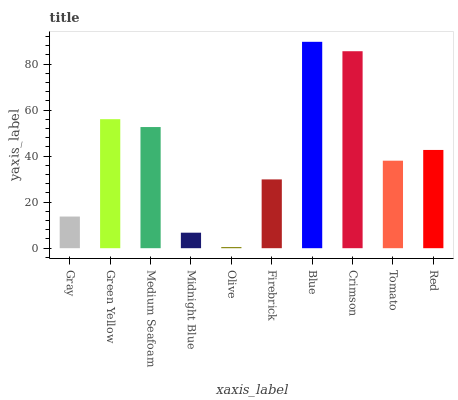Is Olive the minimum?
Answer yes or no. Yes. Is Blue the maximum?
Answer yes or no. Yes. Is Green Yellow the minimum?
Answer yes or no. No. Is Green Yellow the maximum?
Answer yes or no. No. Is Green Yellow greater than Gray?
Answer yes or no. Yes. Is Gray less than Green Yellow?
Answer yes or no. Yes. Is Gray greater than Green Yellow?
Answer yes or no. No. Is Green Yellow less than Gray?
Answer yes or no. No. Is Red the high median?
Answer yes or no. Yes. Is Tomato the low median?
Answer yes or no. Yes. Is Crimson the high median?
Answer yes or no. No. Is Crimson the low median?
Answer yes or no. No. 